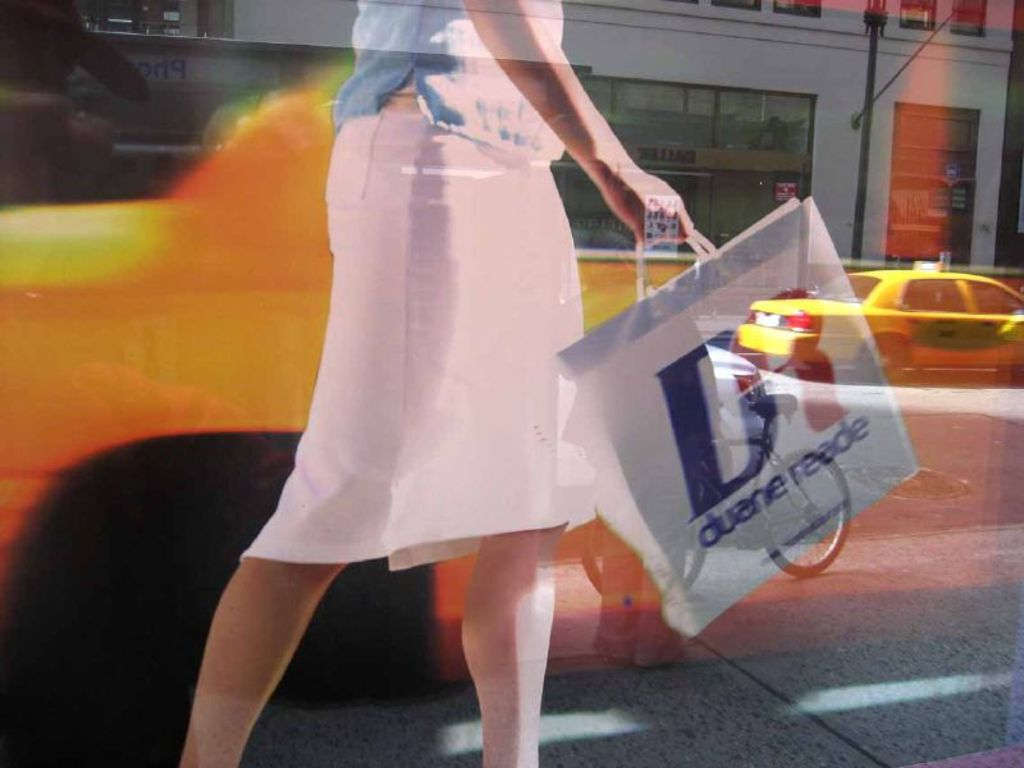What time of day does this image portray, and how can you tell? The image likely portrays daytime, evident from the bright lighting and shadows on the ground, which indicate sunlight. The busy atmosphere and active traffic also support the idea of daytime hours. 